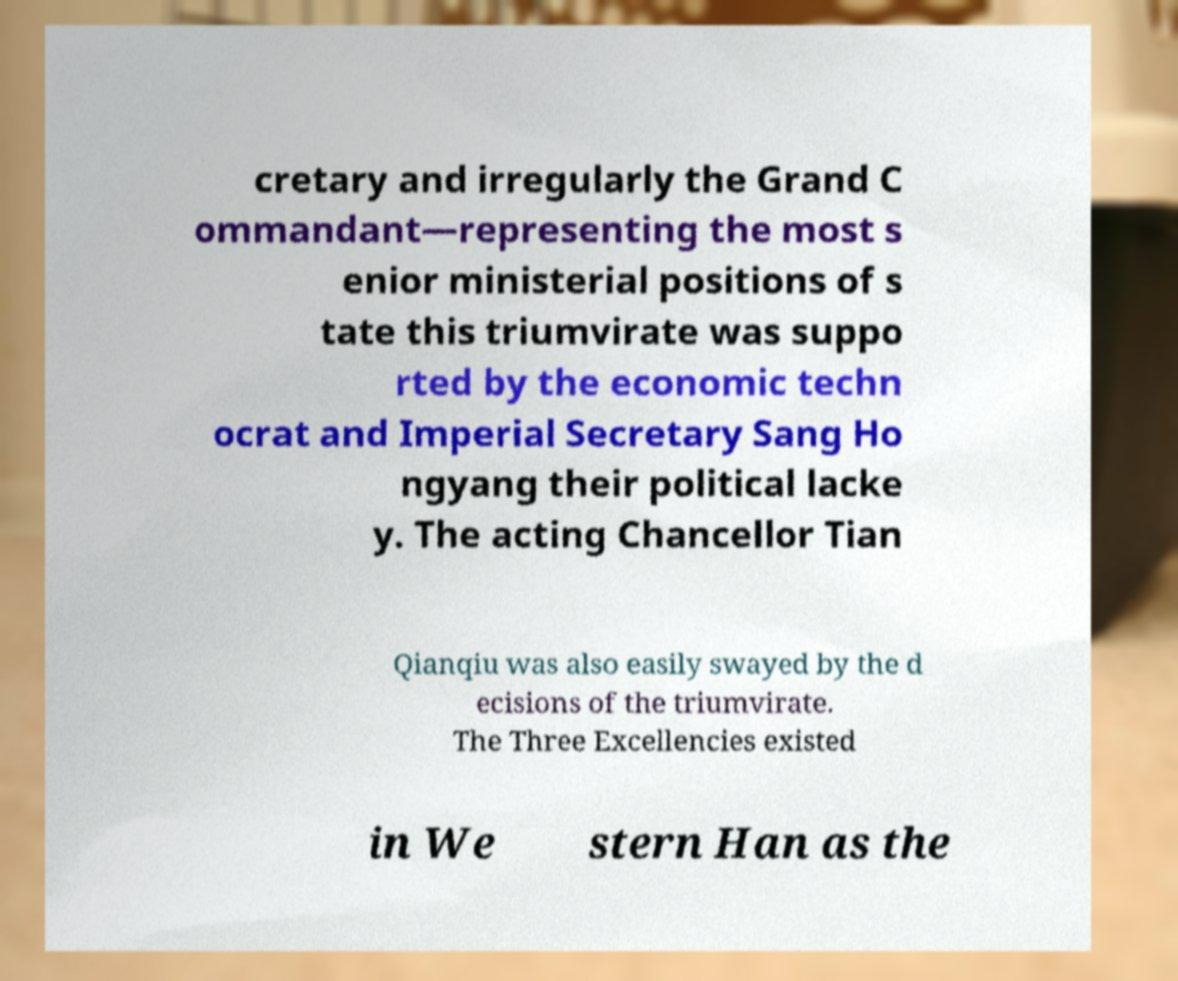There's text embedded in this image that I need extracted. Can you transcribe it verbatim? cretary and irregularly the Grand C ommandant—representing the most s enior ministerial positions of s tate this triumvirate was suppo rted by the economic techn ocrat and Imperial Secretary Sang Ho ngyang their political lacke y. The acting Chancellor Tian Qianqiu was also easily swayed by the d ecisions of the triumvirate. The Three Excellencies existed in We stern Han as the 